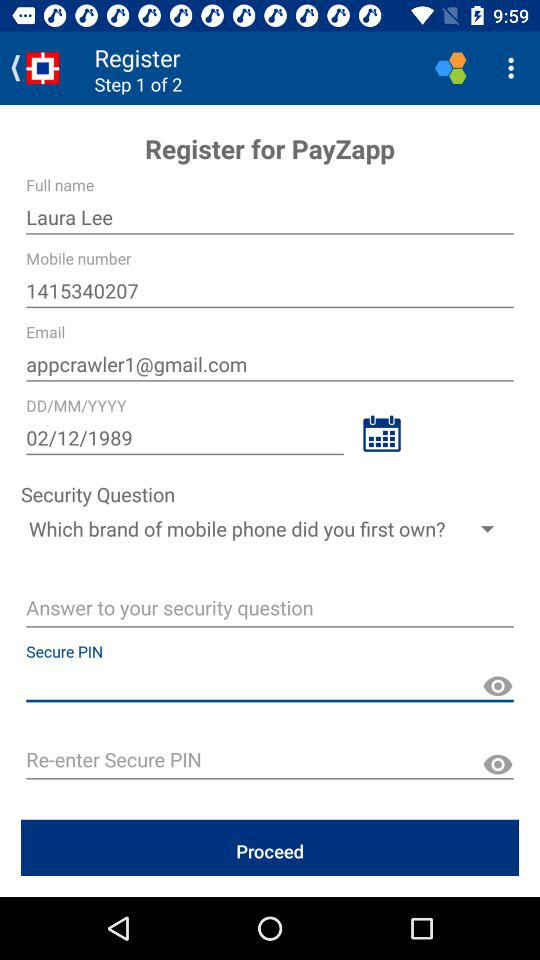What's the total number of steps to register? The total number of steps is 2. 